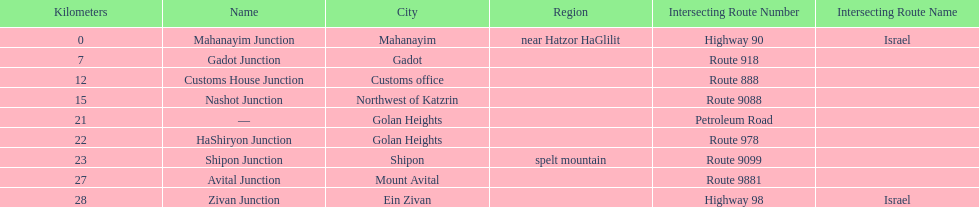Is nashot junction closer to shipon junction or avital junction? Shipon Junction. 